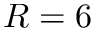<formula> <loc_0><loc_0><loc_500><loc_500>R = 6</formula> 